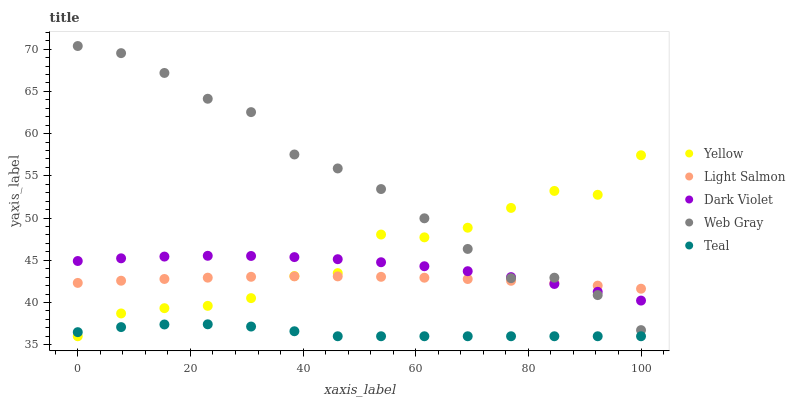Does Teal have the minimum area under the curve?
Answer yes or no. Yes. Does Web Gray have the maximum area under the curve?
Answer yes or no. Yes. Does Light Salmon have the minimum area under the curve?
Answer yes or no. No. Does Light Salmon have the maximum area under the curve?
Answer yes or no. No. Is Light Salmon the smoothest?
Answer yes or no. Yes. Is Yellow the roughest?
Answer yes or no. Yes. Is Web Gray the smoothest?
Answer yes or no. No. Is Web Gray the roughest?
Answer yes or no. No. Does Teal have the lowest value?
Answer yes or no. Yes. Does Web Gray have the lowest value?
Answer yes or no. No. Does Web Gray have the highest value?
Answer yes or no. Yes. Does Light Salmon have the highest value?
Answer yes or no. No. Is Teal less than Light Salmon?
Answer yes or no. Yes. Is Web Gray greater than Teal?
Answer yes or no. Yes. Does Dark Violet intersect Web Gray?
Answer yes or no. Yes. Is Dark Violet less than Web Gray?
Answer yes or no. No. Is Dark Violet greater than Web Gray?
Answer yes or no. No. Does Teal intersect Light Salmon?
Answer yes or no. No. 